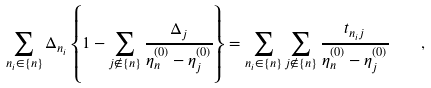<formula> <loc_0><loc_0><loc_500><loc_500>\sum _ { n _ { i } \in \{ n \} } { \Delta _ { n _ { i } } \left \{ 1 - \sum _ { j \not \in \{ n \} } { \frac { \Delta _ { j } } { \eta _ { n } ^ { ( 0 ) } - \eta _ { j } ^ { ( 0 ) } } } \right \} } = \sum _ { n _ { i } \in \{ n \} } { \sum _ { j \not \in \{ n \} } { \frac { t _ { n _ { i } j } } { \eta _ { n } ^ { ( 0 ) } - \eta _ { j } ^ { ( 0 ) } } } } \quad ,</formula> 